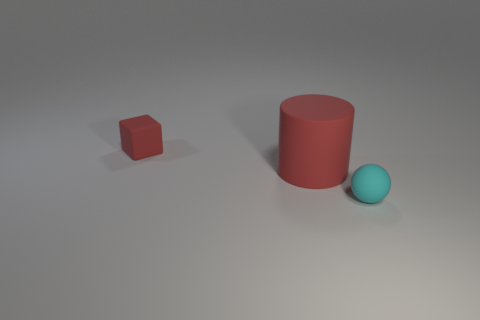Are the object that is behind the large cylinder and the tiny object in front of the red cylinder made of the same material?
Your answer should be very brief. Yes. How many tiny matte objects are there?
Give a very brief answer. 2. How many other things have the same shape as the cyan object?
Provide a short and direct response. 0. Does the big rubber thing have the same shape as the cyan rubber thing?
Provide a short and direct response. No. The cyan ball has what size?
Your answer should be compact. Small. How many cyan matte objects are the same size as the rubber cylinder?
Your answer should be very brief. 0. There is a ball in front of the big cylinder; does it have the same size as the red thing that is in front of the block?
Your answer should be compact. No. What is the shape of the red thing that is on the right side of the tiny red object?
Your response must be concise. Cylinder. What is the object left of the red rubber object in front of the tiny red cube made of?
Make the answer very short. Rubber. Is there a big thing of the same color as the tiny rubber cube?
Your answer should be very brief. Yes. 